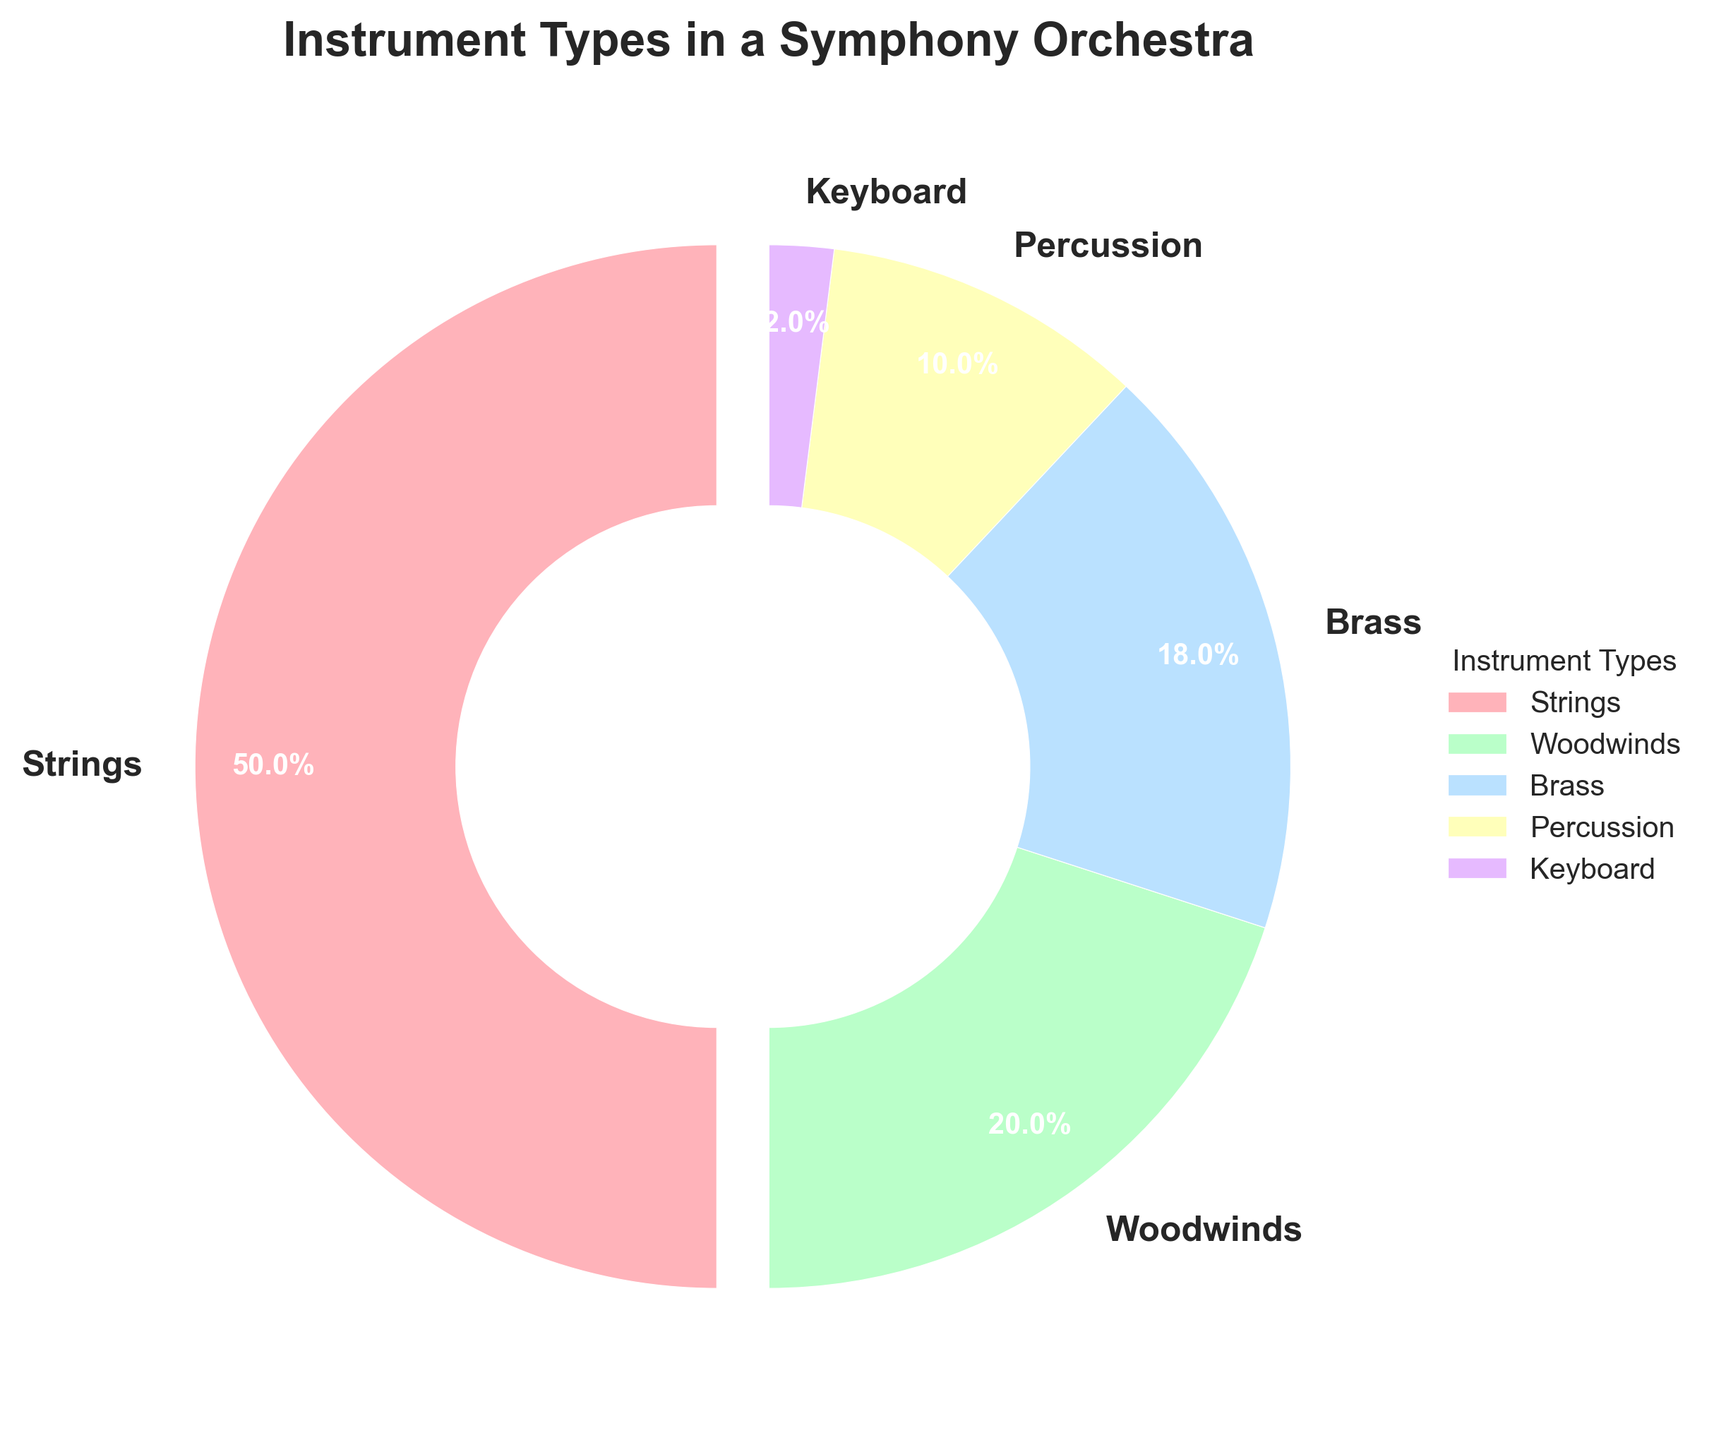What percentage of the orchestra is made up of woodwind instruments? The pie chart shows a segment labeled "Woodwinds" with a percentage value.
Answer: 20% How many instrument types make up the orchestra? Count the number of different labels in the pie chart: Strings, Woodwinds, Brass, Percussion, and Keyboard.
Answer: 5 Which instrument type constitutes the smallest percentage? Identify the segment with the smallest percentage value in the pie chart. The "Keyboard" segment is the smallest.
Answer: Keyboard What is the total percentage of the instruments that are not strings? Subtract the percentage of Strings from 100%. Strings are 50%, so 100% - 50% = 50%.
Answer: 50% How much larger is the percentage of strings compared to brass? Subtract the percentage of Brass from Strings. Strings are 50% and Brass are 18%, so 50% - 18% = 32%.
Answer: 32% Which two instrument types together make up more than half of the orchestra? Combine the percentages of instrument types and find pairs summing more than 50%. Strings (50%) combined with any other type would exceed 50%. Strings and any other instrument pair fits. For example, Strings and Woodwinds: 50% + 20% = 70%.
Answer: Strings and any other type What is the combined percentage of brass and percussion instruments? Add the percentages of Brass (18%) and Percussion (10%). So, 18% + 10% = 28%.
Answer: 28% What color is used to represent the woodwind instruments? Identify the color of the segment labeled "Woodwinds" in the pie chart.
Answer: Green Is the percentage of percussion instruments more than, less than, or equal to the percentage of keyboard instruments? Compare the percentages of Percussion (10%) and Keyboard (2%) in the pie chart. 10% is more than 2%.
Answer: More than By how much does the percentage of woodwinds exceed that of the keyboard instruments? Subtract the percentage of Keyboard from Woodwinds. Woodwinds are 20% and Keyboard are 2%, so 20% - 2% = 18%.
Answer: 18% 